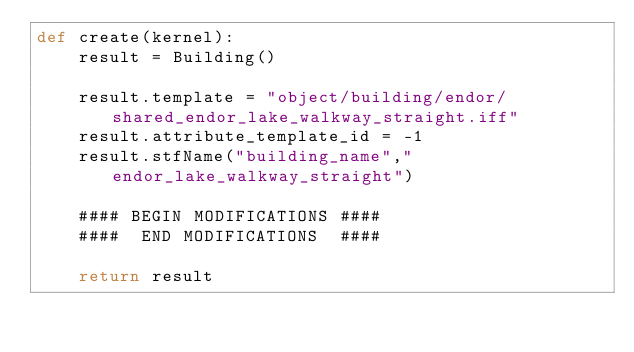<code> <loc_0><loc_0><loc_500><loc_500><_Python_>def create(kernel):
	result = Building()

	result.template = "object/building/endor/shared_endor_lake_walkway_straight.iff"
	result.attribute_template_id = -1
	result.stfName("building_name","endor_lake_walkway_straight")		
	
	#### BEGIN MODIFICATIONS ####
	####  END MODIFICATIONS  ####
	
	return result</code> 